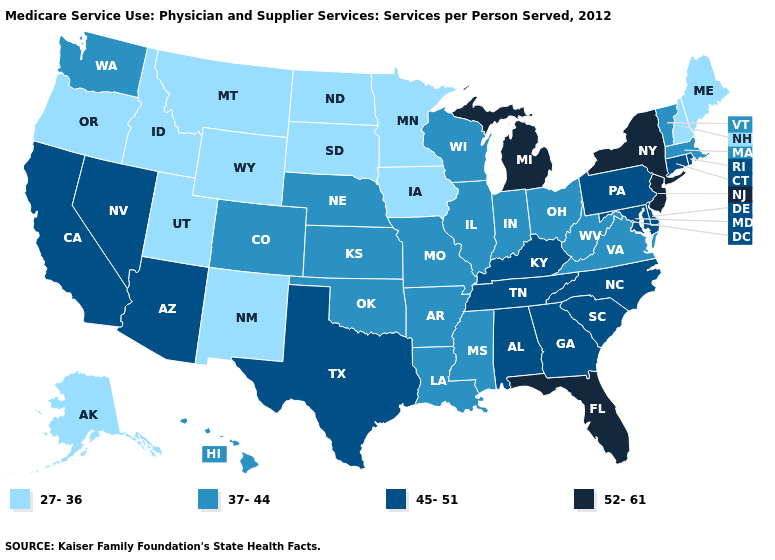What is the highest value in the USA?
Be succinct. 52-61. What is the highest value in the USA?
Concise answer only. 52-61. What is the value of Mississippi?
Quick response, please. 37-44. Which states have the lowest value in the West?
Quick response, please. Alaska, Idaho, Montana, New Mexico, Oregon, Utah, Wyoming. Which states have the lowest value in the West?
Be succinct. Alaska, Idaho, Montana, New Mexico, Oregon, Utah, Wyoming. What is the lowest value in the West?
Quick response, please. 27-36. Name the states that have a value in the range 37-44?
Quick response, please. Arkansas, Colorado, Hawaii, Illinois, Indiana, Kansas, Louisiana, Massachusetts, Mississippi, Missouri, Nebraska, Ohio, Oklahoma, Vermont, Virginia, Washington, West Virginia, Wisconsin. What is the value of North Carolina?
Quick response, please. 45-51. Name the states that have a value in the range 37-44?
Keep it brief. Arkansas, Colorado, Hawaii, Illinois, Indiana, Kansas, Louisiana, Massachusetts, Mississippi, Missouri, Nebraska, Ohio, Oklahoma, Vermont, Virginia, Washington, West Virginia, Wisconsin. Name the states that have a value in the range 45-51?
Keep it brief. Alabama, Arizona, California, Connecticut, Delaware, Georgia, Kentucky, Maryland, Nevada, North Carolina, Pennsylvania, Rhode Island, South Carolina, Tennessee, Texas. Does the map have missing data?
Quick response, please. No. Is the legend a continuous bar?
Write a very short answer. No. What is the lowest value in the USA?
Short answer required. 27-36. 